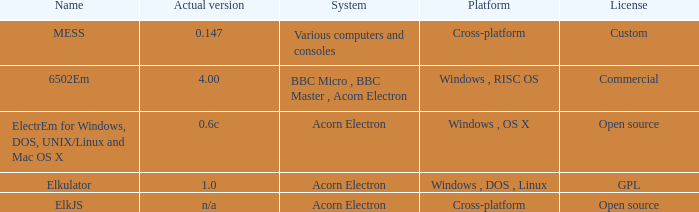What is the system called that is named ELKJS? Acorn Electron. 